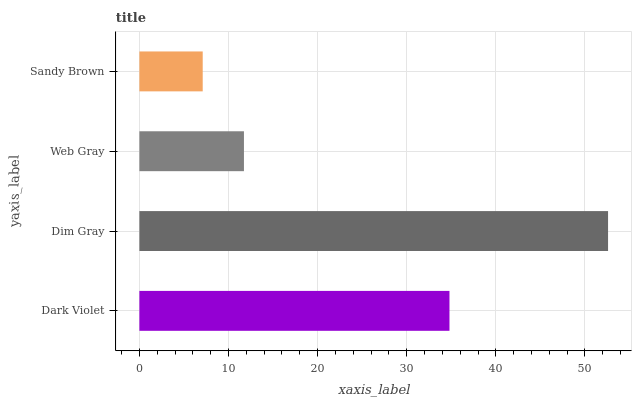Is Sandy Brown the minimum?
Answer yes or no. Yes. Is Dim Gray the maximum?
Answer yes or no. Yes. Is Web Gray the minimum?
Answer yes or no. No. Is Web Gray the maximum?
Answer yes or no. No. Is Dim Gray greater than Web Gray?
Answer yes or no. Yes. Is Web Gray less than Dim Gray?
Answer yes or no. Yes. Is Web Gray greater than Dim Gray?
Answer yes or no. No. Is Dim Gray less than Web Gray?
Answer yes or no. No. Is Dark Violet the high median?
Answer yes or no. Yes. Is Web Gray the low median?
Answer yes or no. Yes. Is Dim Gray the high median?
Answer yes or no. No. Is Dim Gray the low median?
Answer yes or no. No. 